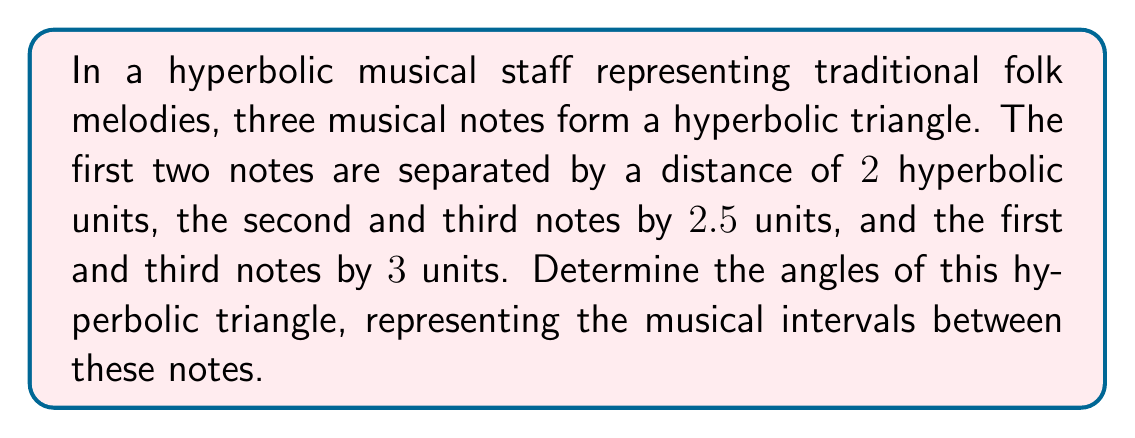Can you answer this question? Let's approach this step-by-step using the hyperbolic law of cosines:

1) In a hyperbolic triangle with sides $a$, $b$, and $c$, and opposite angles $A$, $B$, and $C$, the hyperbolic law of cosines states:

   $$\cosh c = \cosh a \cosh b - \sinh a \sinh b \cos C$$

2) We have $a = 2$, $b = 2.5$, and $c = 3$. Let's calculate angle $C$ first:

   $$\cosh 3 = \cosh 2 \cosh 2.5 - \sinh 2 \sinh 2.5 \cos C$$

3) Calculate the hyperbolic functions:
   
   $\cosh 3 \approx 10.0677$
   $\cosh 2 \approx 3.7622$
   $\cosh 2.5 \approx 6.1322$
   $\sinh 2 \approx 3.6269$
   $\sinh 2.5 \approx 6.0502$

4) Substitute these values:

   $$10.0677 = 3.7622 \cdot 6.1322 - 3.6269 \cdot 6.0502 \cos C$$

5) Solve for $\cos C$:

   $$\cos C = \frac{3.7622 \cdot 6.1322 - 10.0677}{3.6269 \cdot 6.0502} \approx 0.2654$$

6) Therefore, $C = \arccos(0.2654) \approx 1.3052$ radians or $74.76°$

7) Repeat this process for angles $A$ and $B$, using the appropriate side lengths.

8) For angle $A$:

   $$\cosh 2.5 = \cosh 3 \cosh 2 - \sinh 3 \sinh 2 \cos A$$

   Solving this gives $A \approx 0.7853$ radians or $45.00°$

9) For angle $B$:

   $$\cosh 2 = \cosh 3 \cosh 2.5 - \sinh 3 \sinh 2.5 \cos B$$

   Solving this gives $B \approx 1.0517$ radians or $60.24°$

10) Verify that the sum of the angles is less than $180°$, which is a property of hyperbolic triangles.
Answer: $A \approx 45.00°$, $B \approx 60.24°$, $C \approx 74.76°$ 